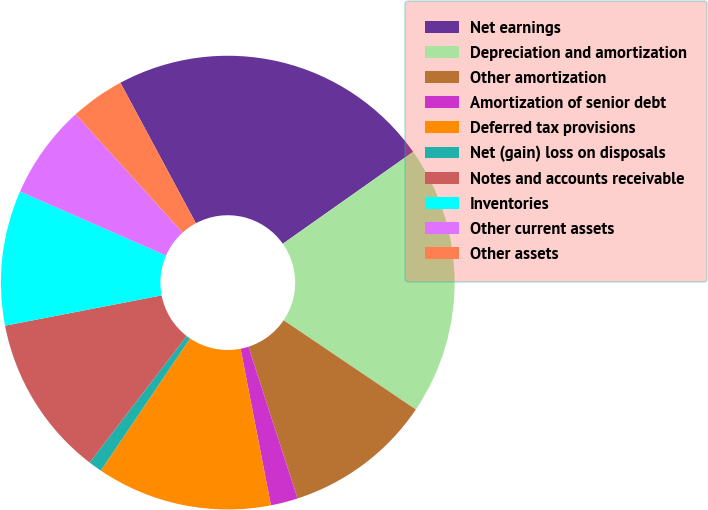Convert chart to OTSL. <chart><loc_0><loc_0><loc_500><loc_500><pie_chart><fcel>Net earnings<fcel>Depreciation and amortization<fcel>Other amortization<fcel>Amortization of senior debt<fcel>Deferred tax provisions<fcel>Net (gain) loss on disposals<fcel>Notes and accounts receivable<fcel>Inventories<fcel>Other current assets<fcel>Other assets<nl><fcel>23.07%<fcel>19.23%<fcel>10.58%<fcel>1.93%<fcel>12.5%<fcel>0.97%<fcel>11.54%<fcel>9.62%<fcel>6.73%<fcel>3.85%<nl></chart> 